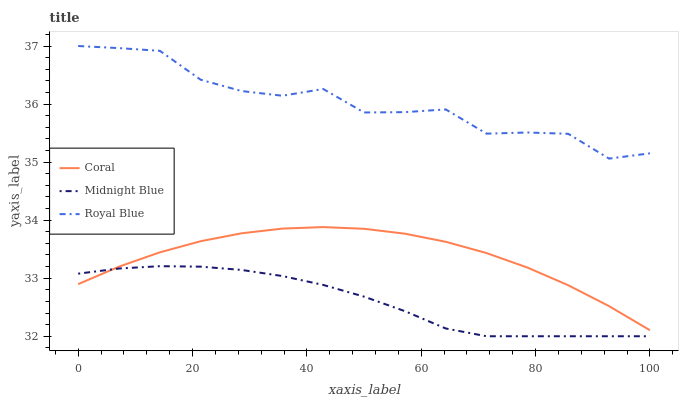Does Midnight Blue have the minimum area under the curve?
Answer yes or no. Yes. Does Royal Blue have the maximum area under the curve?
Answer yes or no. Yes. Does Coral have the minimum area under the curve?
Answer yes or no. No. Does Coral have the maximum area under the curve?
Answer yes or no. No. Is Midnight Blue the smoothest?
Answer yes or no. Yes. Is Royal Blue the roughest?
Answer yes or no. Yes. Is Coral the smoothest?
Answer yes or no. No. Is Coral the roughest?
Answer yes or no. No. Does Midnight Blue have the lowest value?
Answer yes or no. Yes. Does Coral have the lowest value?
Answer yes or no. No. Does Royal Blue have the highest value?
Answer yes or no. Yes. Does Coral have the highest value?
Answer yes or no. No. Is Midnight Blue less than Royal Blue?
Answer yes or no. Yes. Is Royal Blue greater than Coral?
Answer yes or no. Yes. Does Coral intersect Midnight Blue?
Answer yes or no. Yes. Is Coral less than Midnight Blue?
Answer yes or no. No. Is Coral greater than Midnight Blue?
Answer yes or no. No. Does Midnight Blue intersect Royal Blue?
Answer yes or no. No. 